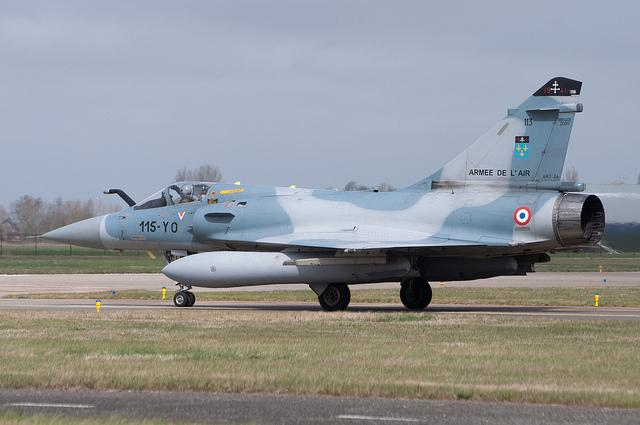What country does this plane belong to? france 